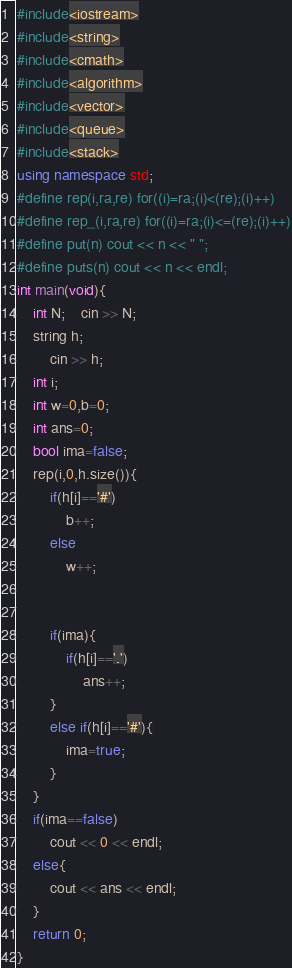Convert code to text. <code><loc_0><loc_0><loc_500><loc_500><_C++_>#include<iostream>
#include<string>
#include<cmath>
#include<algorithm>
#include<vector>
#include<queue>
#include<stack>
using namespace std;
#define rep(i,ra,re) for((i)=ra;(i)<(re);(i)++)
#define rep_(i,ra,re) for((i)=ra;(i)<=(re);(i)++)
#define put(n) cout << n << " "; 
#define puts(n) cout << n << endl;
int main(void){
	int N;	cin >> N;
	string h;
		cin >> h;
	int i;
	int w=0,b=0;
	int ans=0;
	bool ima=false;
	rep(i,0,h.size()){
		if(h[i]=='#')
			b++;
		else
			w++;
		
		
		if(ima){
			if(h[i]=='.')
				ans++;
		}
		else if(h[i]=='#'){
			ima=true;
		}
	}
	if(ima==false)
		cout << 0 << endl;
	else{
		cout << ans << endl;
	}
	return 0;
}</code> 